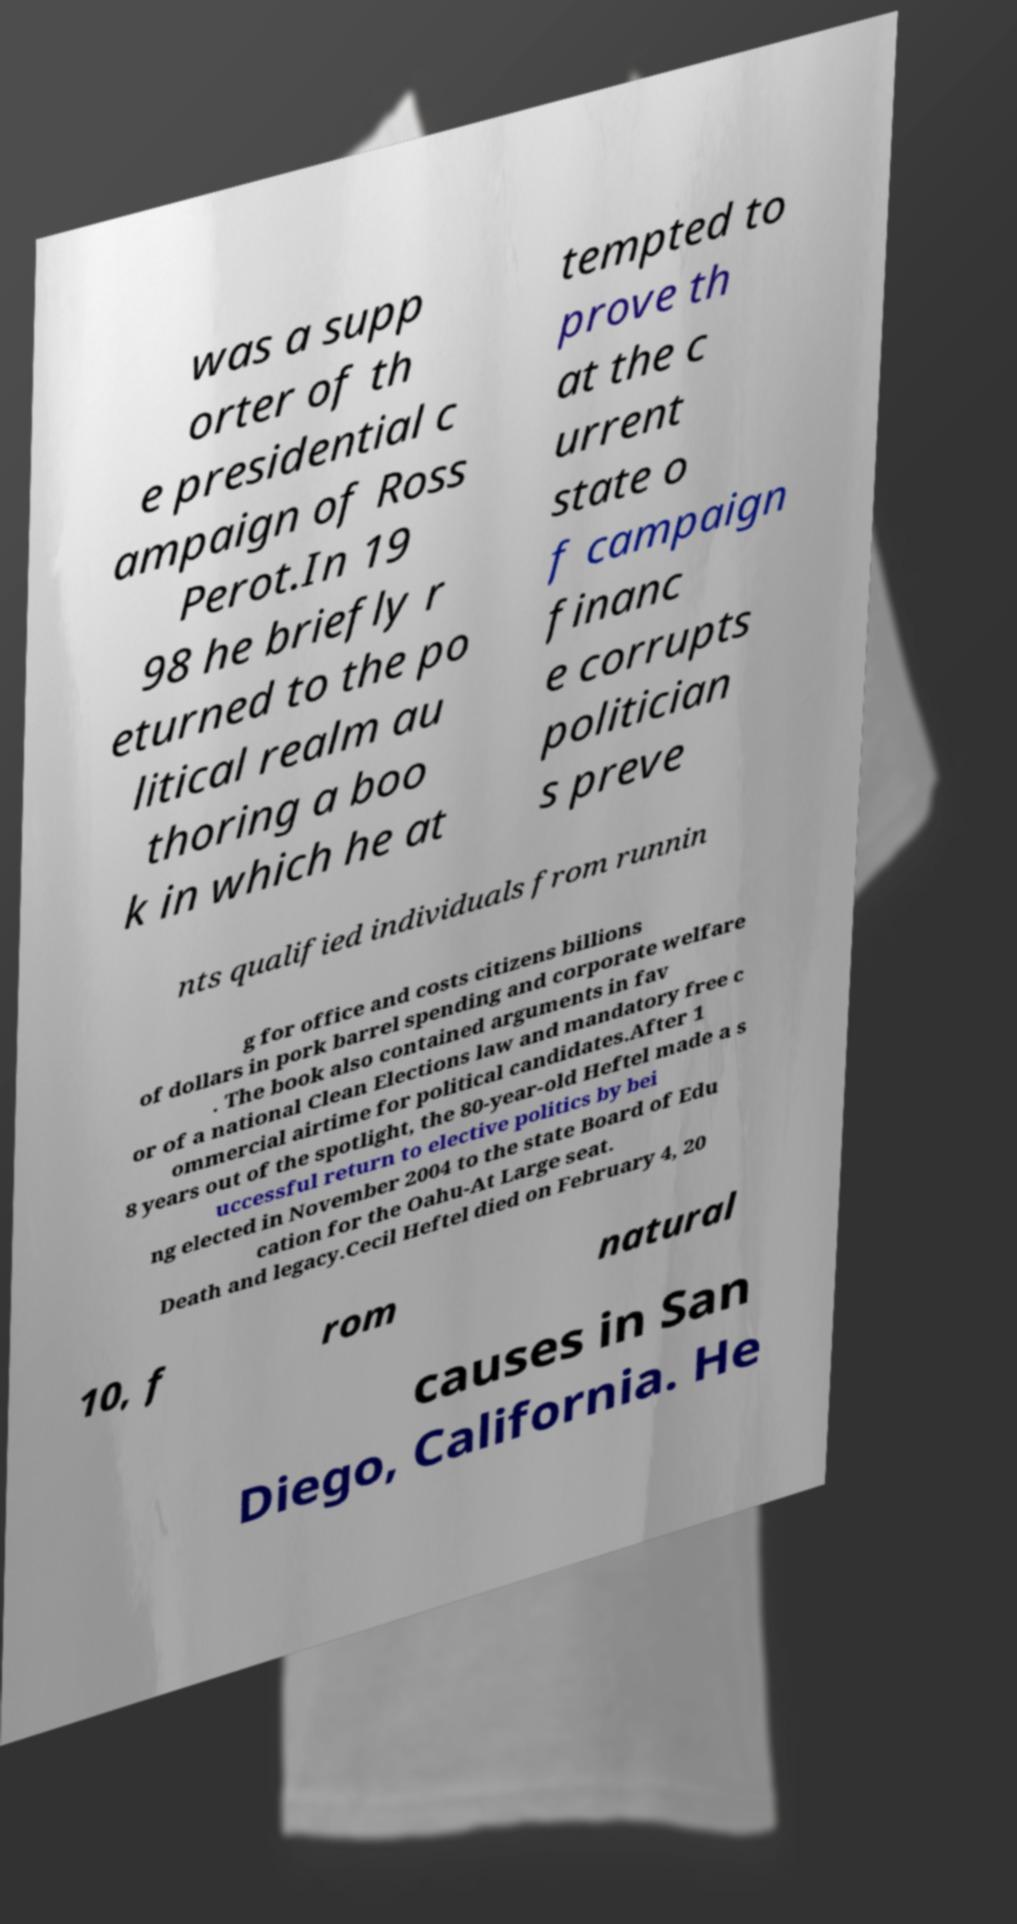There's text embedded in this image that I need extracted. Can you transcribe it verbatim? was a supp orter of th e presidential c ampaign of Ross Perot.In 19 98 he briefly r eturned to the po litical realm au thoring a boo k in which he at tempted to prove th at the c urrent state o f campaign financ e corrupts politician s preve nts qualified individuals from runnin g for office and costs citizens billions of dollars in pork barrel spending and corporate welfare . The book also contained arguments in fav or of a national Clean Elections law and mandatory free c ommercial airtime for political candidates.After 1 8 years out of the spotlight, the 80-year-old Heftel made a s uccessful return to elective politics by bei ng elected in November 2004 to the state Board of Edu cation for the Oahu-At Large seat. Death and legacy.Cecil Heftel died on February 4, 20 10, f rom natural causes in San Diego, California. He 